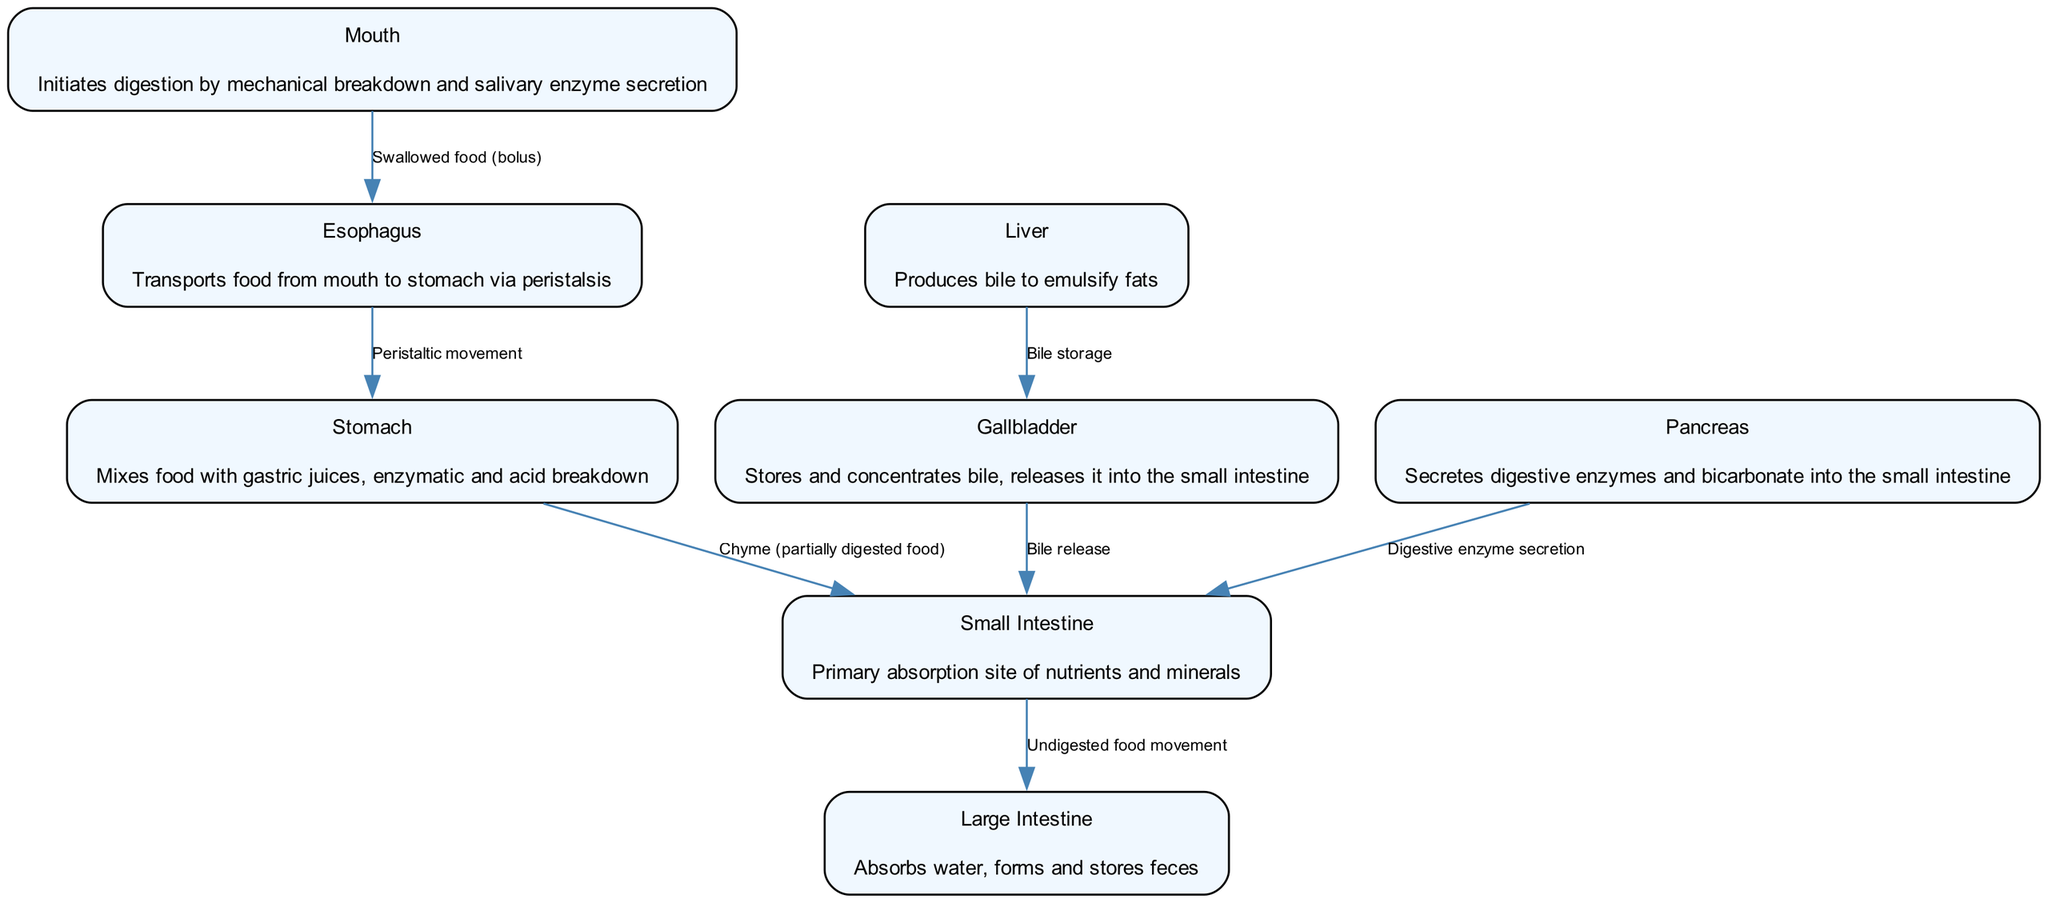What is the functional annotation of the stomach? The stomach is described in the diagram as mixing food with gastric juices, indicating its role in enzymatic and acid breakdown. This is found in the node labeled "Stomach."
Answer: Mixes food with gastric juices, enzymatic and acid breakdown How many organs are involved in the digestive process as represented in the diagram? The diagram features eight distinct nodes representing organs involved in digestion: mouth, esophagus, stomach, liver, gallbladder, pancreas, small intestine, and large intestine.
Answer: 8 What is the relationship between the gallbladder and the small intestine? The edge connecting the gallbladder to the small intestine states that the gallbladder releases bile into the small intestine, indicating a direct functional linkage between these organs during digestion.
Answer: Bile release What type of movement does the esophagus facilitate? According to the edge from the esophagus, it facilitates peristaltic movement to transport food to the stomach. This is indicated on the connecting edge labeled "Peristaltic movement."
Answer: Peristaltic movement What does the liver produce for fat digestion? The liver is annotated in the diagram as producing bile, which is crucial for the emulsification of fats during the digestive process. This information can be found in the node for the liver.
Answer: Bile What occurs when food leaves the stomach? The diagram indicates that when food leaves the stomach, it is in the form of chyme, which is partially digested food, being transported to the small intestine.
Answer: Chyme (partially digested food) What does the large intestine primarily absorb? The node for the large intestine states that it absorbs water and stores feces, indicating its main role in processing waste post-digestion.
Answer: Water How does the pancreas contribute to digestion? The pancreas is represented as secreting digestive enzymes and bicarbonate into the small intestine, showing its critical role in digesting food during this phase of the process.
Answer: Digestive enzyme secretion 